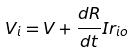<formula> <loc_0><loc_0><loc_500><loc_500>V _ { i } = V + \frac { d R } { d t } I r _ { i o }</formula> 